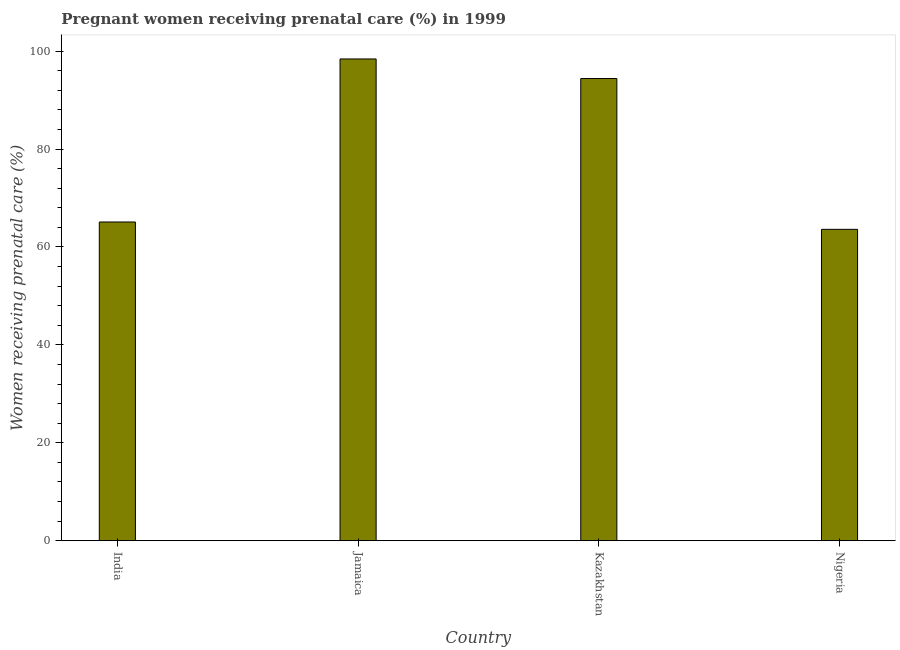Does the graph contain any zero values?
Ensure brevity in your answer.  No. What is the title of the graph?
Provide a short and direct response. Pregnant women receiving prenatal care (%) in 1999. What is the label or title of the Y-axis?
Your response must be concise. Women receiving prenatal care (%). What is the percentage of pregnant women receiving prenatal care in Kazakhstan?
Offer a terse response. 94.4. Across all countries, what is the maximum percentage of pregnant women receiving prenatal care?
Your answer should be very brief. 98.4. Across all countries, what is the minimum percentage of pregnant women receiving prenatal care?
Your response must be concise. 63.6. In which country was the percentage of pregnant women receiving prenatal care maximum?
Offer a very short reply. Jamaica. In which country was the percentage of pregnant women receiving prenatal care minimum?
Ensure brevity in your answer.  Nigeria. What is the sum of the percentage of pregnant women receiving prenatal care?
Give a very brief answer. 321.5. What is the difference between the percentage of pregnant women receiving prenatal care in Kazakhstan and Nigeria?
Keep it short and to the point. 30.8. What is the average percentage of pregnant women receiving prenatal care per country?
Offer a very short reply. 80.38. What is the median percentage of pregnant women receiving prenatal care?
Keep it short and to the point. 79.75. In how many countries, is the percentage of pregnant women receiving prenatal care greater than 40 %?
Make the answer very short. 4. What is the ratio of the percentage of pregnant women receiving prenatal care in Jamaica to that in Nigeria?
Make the answer very short. 1.55. Is the percentage of pregnant women receiving prenatal care in Jamaica less than that in Nigeria?
Your response must be concise. No. What is the difference between the highest and the second highest percentage of pregnant women receiving prenatal care?
Offer a very short reply. 4. What is the difference between the highest and the lowest percentage of pregnant women receiving prenatal care?
Give a very brief answer. 34.8. Are all the bars in the graph horizontal?
Your answer should be very brief. No. How many countries are there in the graph?
Ensure brevity in your answer.  4. What is the difference between two consecutive major ticks on the Y-axis?
Give a very brief answer. 20. What is the Women receiving prenatal care (%) of India?
Your answer should be compact. 65.1. What is the Women receiving prenatal care (%) of Jamaica?
Your answer should be compact. 98.4. What is the Women receiving prenatal care (%) of Kazakhstan?
Keep it short and to the point. 94.4. What is the Women receiving prenatal care (%) in Nigeria?
Your answer should be very brief. 63.6. What is the difference between the Women receiving prenatal care (%) in India and Jamaica?
Offer a terse response. -33.3. What is the difference between the Women receiving prenatal care (%) in India and Kazakhstan?
Your answer should be compact. -29.3. What is the difference between the Women receiving prenatal care (%) in Jamaica and Nigeria?
Offer a terse response. 34.8. What is the difference between the Women receiving prenatal care (%) in Kazakhstan and Nigeria?
Provide a short and direct response. 30.8. What is the ratio of the Women receiving prenatal care (%) in India to that in Jamaica?
Give a very brief answer. 0.66. What is the ratio of the Women receiving prenatal care (%) in India to that in Kazakhstan?
Ensure brevity in your answer.  0.69. What is the ratio of the Women receiving prenatal care (%) in Jamaica to that in Kazakhstan?
Make the answer very short. 1.04. What is the ratio of the Women receiving prenatal care (%) in Jamaica to that in Nigeria?
Your response must be concise. 1.55. What is the ratio of the Women receiving prenatal care (%) in Kazakhstan to that in Nigeria?
Make the answer very short. 1.48. 